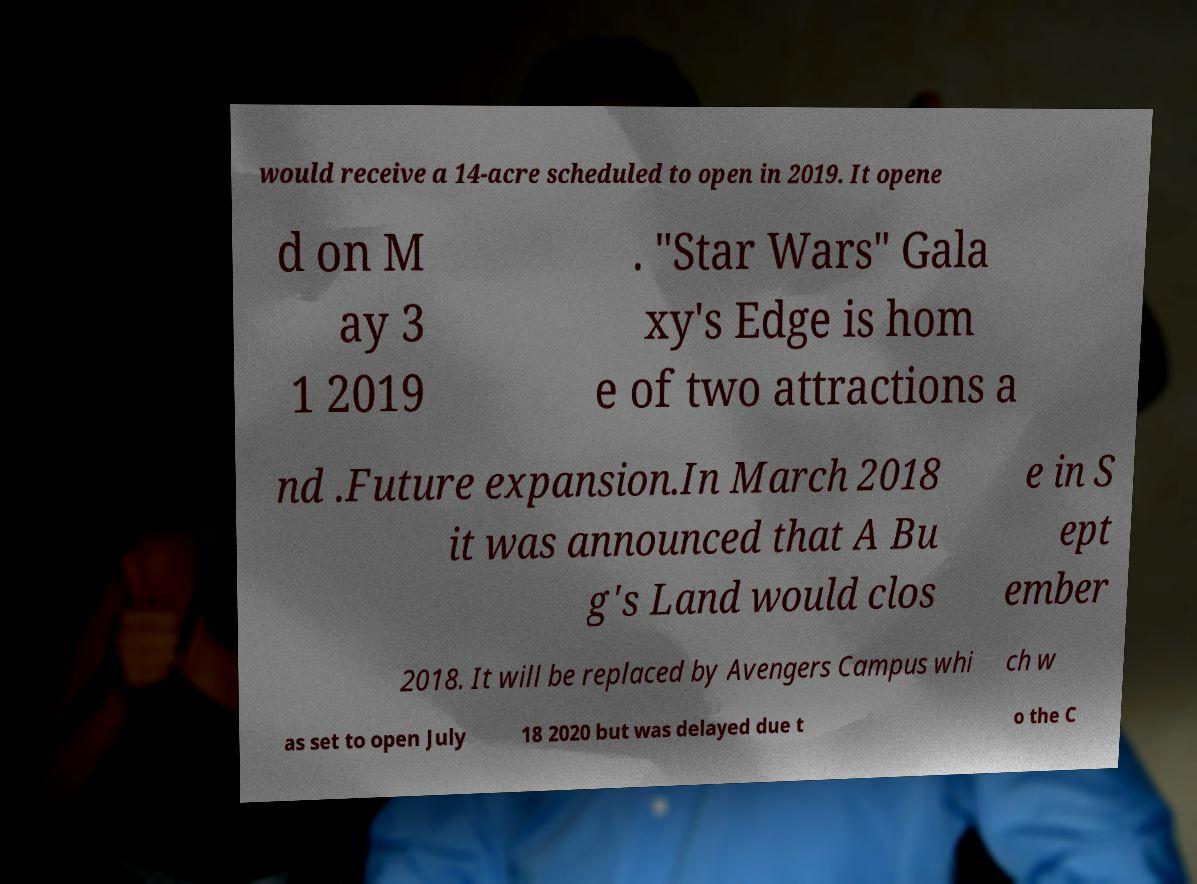There's text embedded in this image that I need extracted. Can you transcribe it verbatim? would receive a 14-acre scheduled to open in 2019. It opene d on M ay 3 1 2019 . "Star Wars" Gala xy's Edge is hom e of two attractions a nd .Future expansion.In March 2018 it was announced that A Bu g's Land would clos e in S ept ember 2018. It will be replaced by Avengers Campus whi ch w as set to open July 18 2020 but was delayed due t o the C 